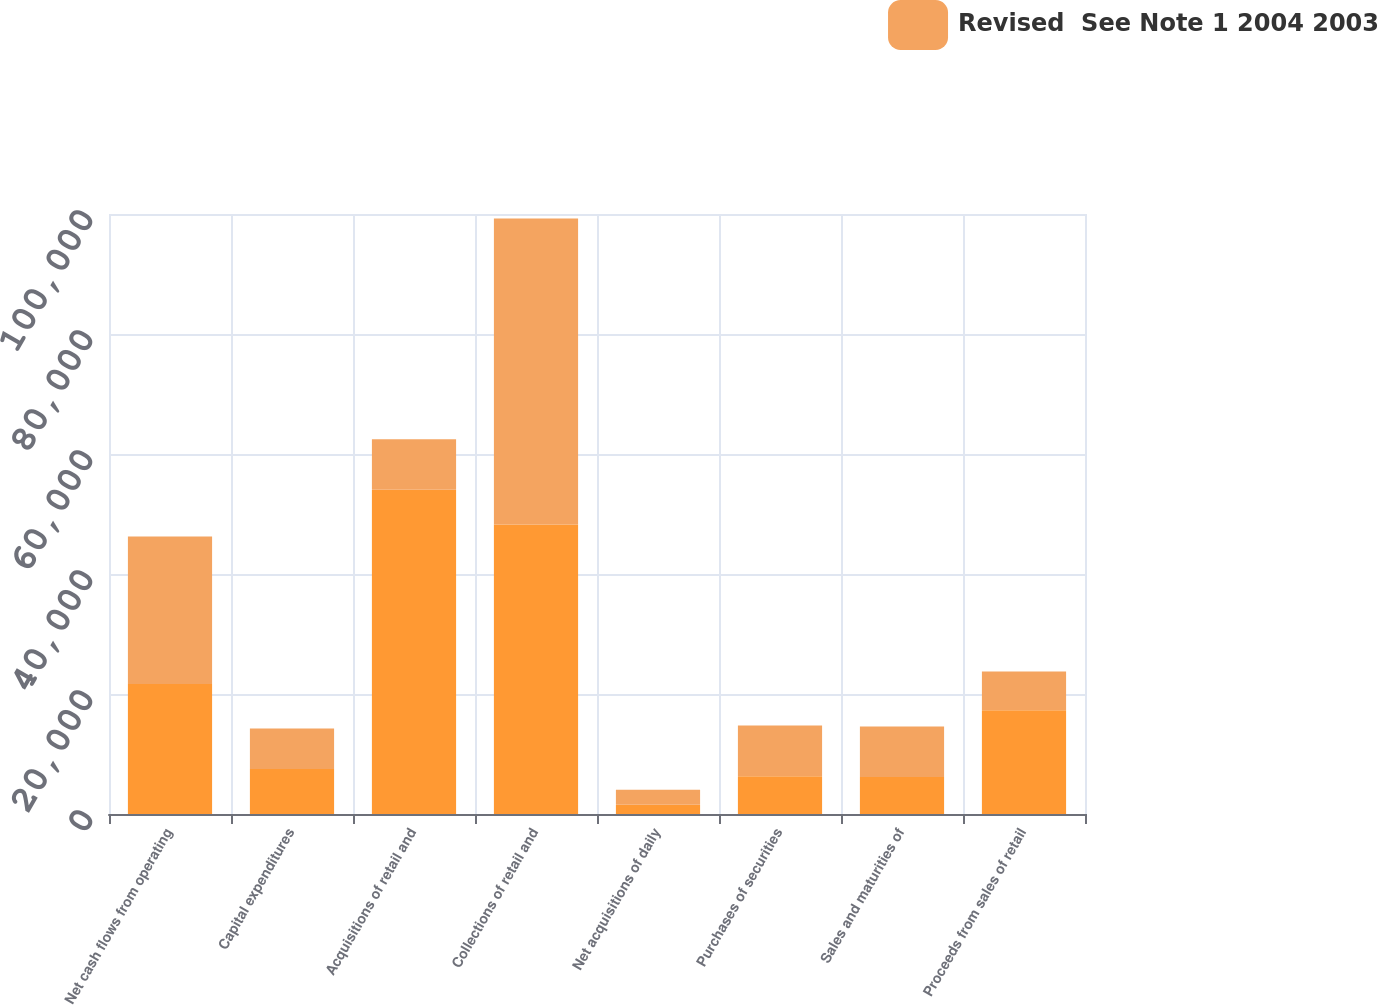Convert chart. <chart><loc_0><loc_0><loc_500><loc_500><stacked_bar_chart><ecel><fcel>Net cash flows from operating<fcel>Capital expenditures<fcel>Acquisitions of retail and<fcel>Collections of retail and<fcel>Net acquisitions of daily<fcel>Purchases of securities<fcel>Sales and maturities of<fcel>Proceeds from sales of retail<nl><fcel>nan<fcel>21674<fcel>7517<fcel>54024<fcel>48238<fcel>1552<fcel>6278<fcel>6154<fcel>17288<nl><fcel>Revised  See Note 1 2004 2003<fcel>24562<fcel>6738<fcel>8414<fcel>51024<fcel>2492<fcel>8470<fcel>8414<fcel>6481<nl></chart> 